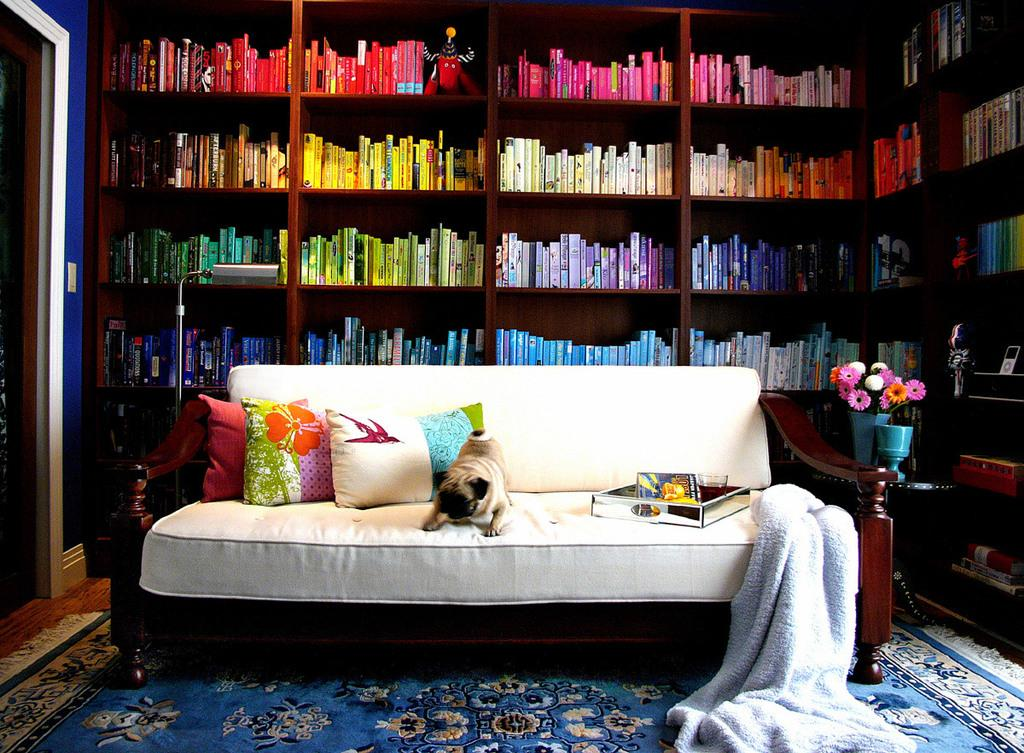What can be seen on the rack in the image? There are many books on the rack in the image. What can be seen on the couch in the image? There are few pillows on the couch in the image. What type of animal is present in the image? There is a dog in the image. What is visible at the right side of the image? There are objects visible at the right side of the image. Is there a stocking hanging on the wall in the image? There is no stocking hanging on the wall in the image. What type of locket is the dog wearing in the image? There is no locket present in the image, as the dog is not wearing any accessories. 